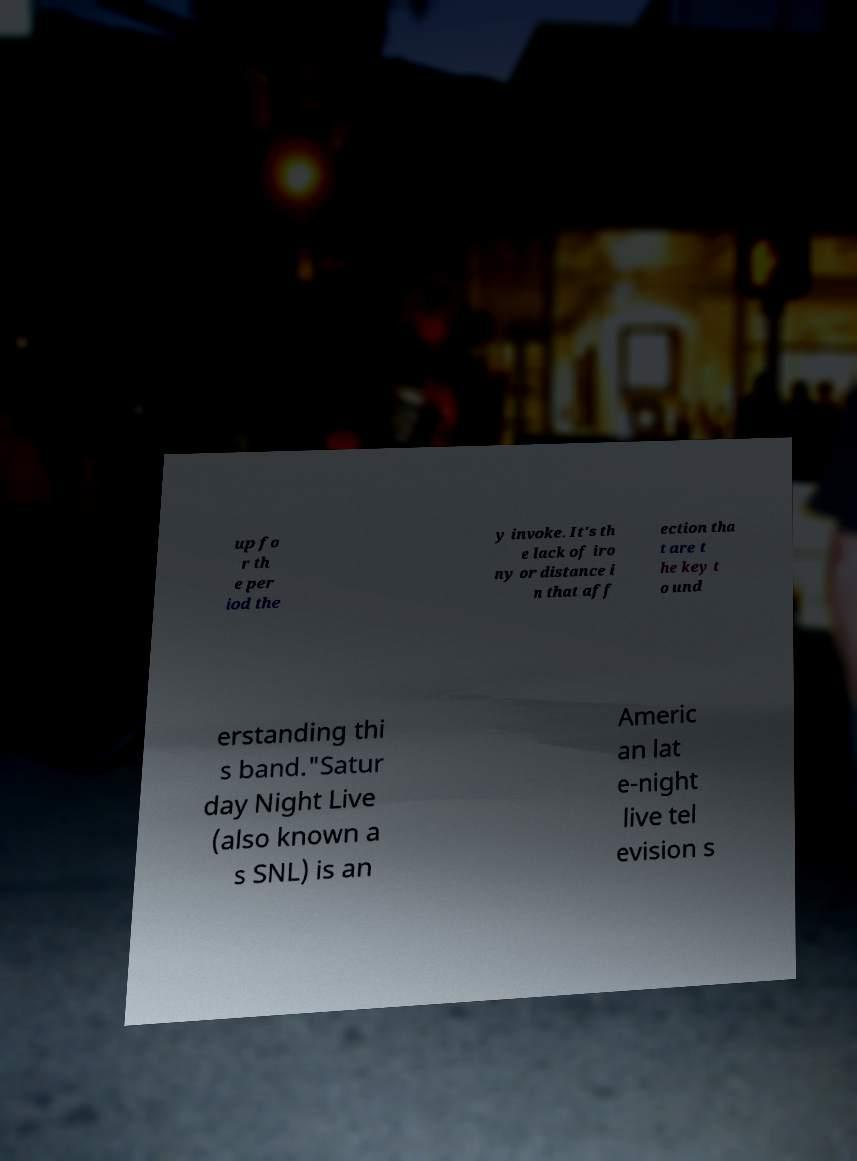Please read and relay the text visible in this image. What does it say? up fo r th e per iod the y invoke. It's th e lack of iro ny or distance i n that aff ection tha t are t he key t o und erstanding thi s band."Satur day Night Live (also known a s SNL) is an Americ an lat e-night live tel evision s 